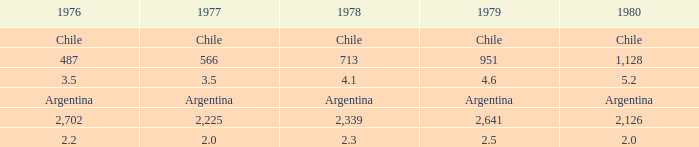What is 1976 when 1980 is 2.0? 2.2. 